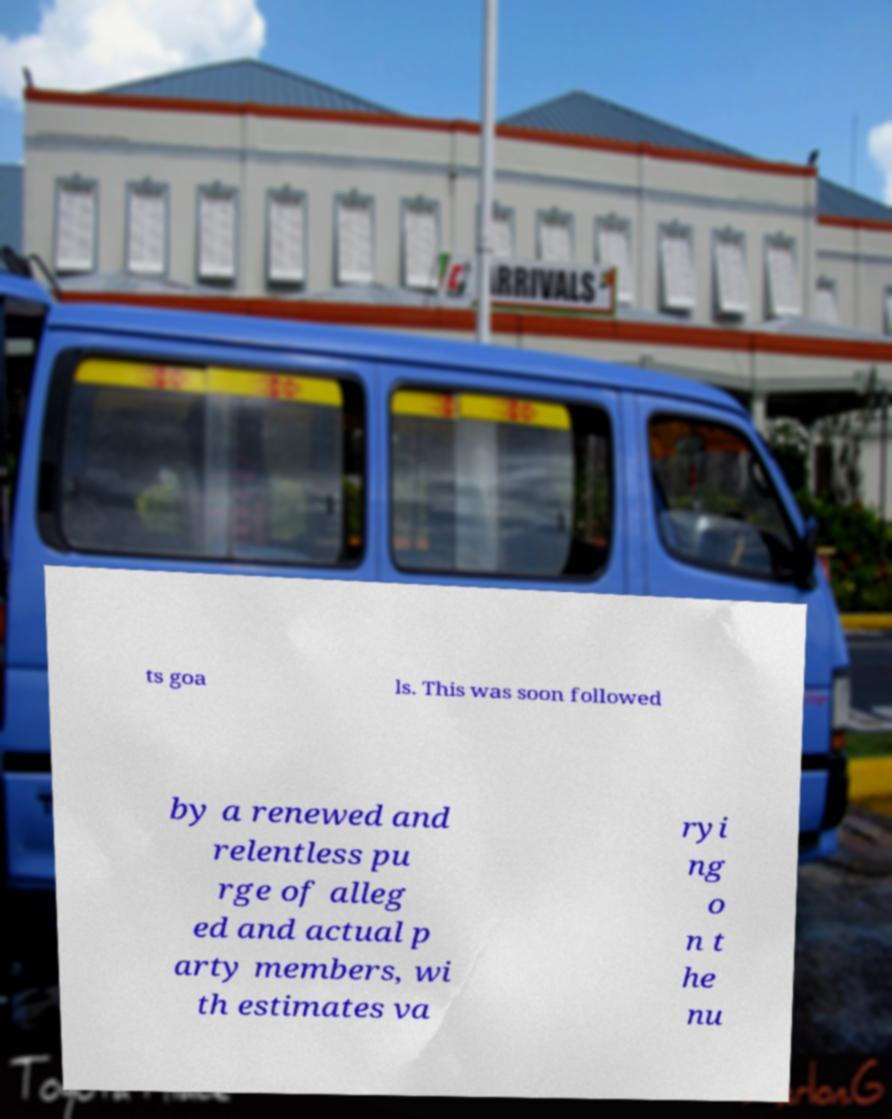I need the written content from this picture converted into text. Can you do that? ts goa ls. This was soon followed by a renewed and relentless pu rge of alleg ed and actual p arty members, wi th estimates va ryi ng o n t he nu 